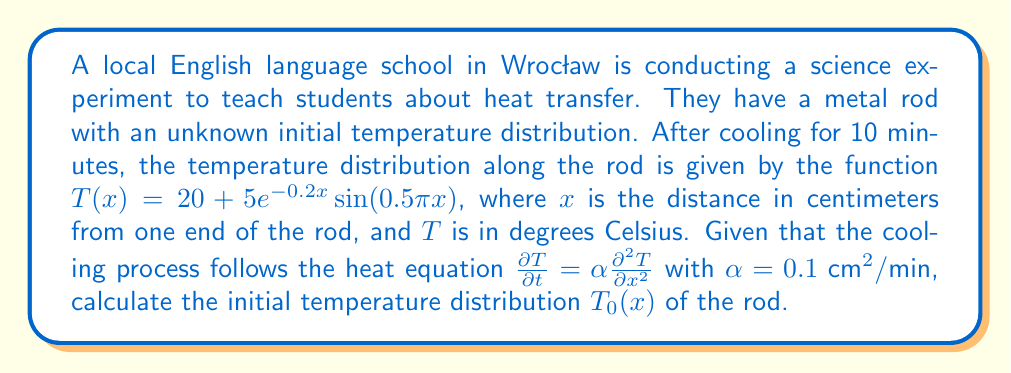Show me your answer to this math problem. To solve this inverse problem, we need to work backwards from the final state to determine the initial temperature distribution. We'll use the separation of variables method and the properties of the heat equation.

Step 1: Assume the solution has the form $T(x,t) = X(x)e^{-\lambda t}$.

Step 2: Substituting into the heat equation:
$$\frac{\partial T}{\partial t} = -\lambda X(x)e^{-\lambda t} = \alpha \frac{\partial^2 T}{\partial x^2} = \alpha X''(x)e^{-\lambda t}$$

Step 3: This leads to the eigenvalue problem:
$$X''(x) + \frac{\lambda}{\alpha}X(x) = 0$$

Step 4: The general solution for $X(x)$ is:
$$X(x) = A \sin(\sqrt{\frac{\lambda}{\alpha}}x) + B \cos(\sqrt{\frac{\lambda}{\alpha}}x)$$

Step 5: Given the final state $T(x) = 20 + 5e^{-0.2x} \sin(0.5\pi x)$, we can identify:
$$\sqrt{\frac{\lambda}{\alpha}} = 0.5\pi$$
$$\lambda = 0.25\pi^2\alpha = 0.25\pi^2 \cdot 0.1 = 0.025\pi^2$$

Step 6: The time-dependent part is $e^{-\lambda t} = e^{-0.025\pi^2 \cdot 10} \approx 0.0858$

Step 7: To find the initial distribution $T_0(x)$, we need to divide the final state by $e^{-\lambda t}$:

$$T_0(x) = 20 + \frac{5e^{-0.2x} \sin(0.5\pi x)}{0.0858}$$

Step 8: Simplify:
$$T_0(x) = 20 + 58.28e^{-0.2x} \sin(0.5\pi x)$$
Answer: $T_0(x) = 20 + 58.28e^{-0.2x} \sin(0.5\pi x)$ 